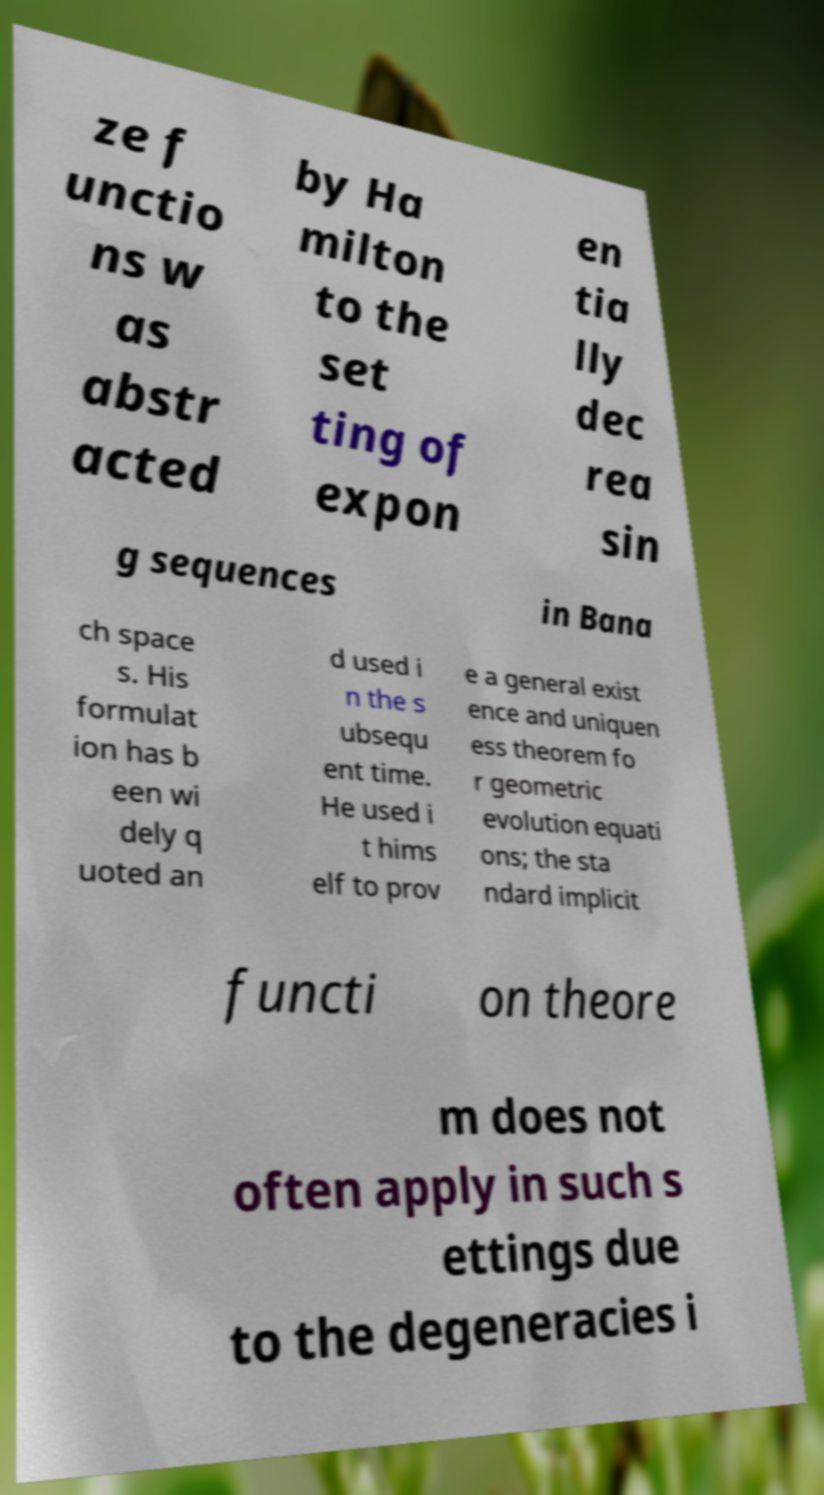For documentation purposes, I need the text within this image transcribed. Could you provide that? ze f unctio ns w as abstr acted by Ha milton to the set ting of expon en tia lly dec rea sin g sequences in Bana ch space s. His formulat ion has b een wi dely q uoted an d used i n the s ubsequ ent time. He used i t hims elf to prov e a general exist ence and uniquen ess theorem fo r geometric evolution equati ons; the sta ndard implicit functi on theore m does not often apply in such s ettings due to the degeneracies i 